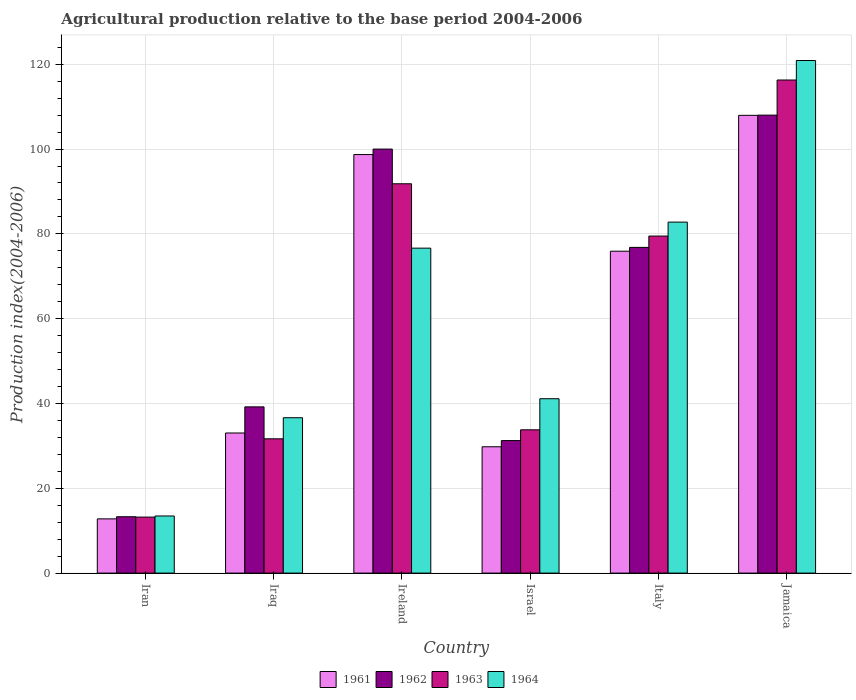How many different coloured bars are there?
Give a very brief answer. 4. Are the number of bars per tick equal to the number of legend labels?
Ensure brevity in your answer.  Yes. Are the number of bars on each tick of the X-axis equal?
Your answer should be very brief. Yes. How many bars are there on the 2nd tick from the right?
Your answer should be very brief. 4. What is the label of the 1st group of bars from the left?
Make the answer very short. Iran. What is the agricultural production index in 1964 in Italy?
Give a very brief answer. 82.77. Across all countries, what is the maximum agricultural production index in 1962?
Keep it short and to the point. 108. Across all countries, what is the minimum agricultural production index in 1964?
Make the answer very short. 13.47. In which country was the agricultural production index in 1961 maximum?
Offer a very short reply. Jamaica. In which country was the agricultural production index in 1961 minimum?
Offer a very short reply. Iran. What is the total agricultural production index in 1962 in the graph?
Your answer should be compact. 368.54. What is the difference between the agricultural production index in 1961 in Italy and that in Jamaica?
Provide a succinct answer. -32.04. What is the difference between the agricultural production index in 1961 in Iraq and the agricultural production index in 1963 in Ireland?
Give a very brief answer. -58.77. What is the average agricultural production index in 1963 per country?
Ensure brevity in your answer.  61.04. What is the difference between the agricultural production index of/in 1962 and agricultural production index of/in 1964 in Iran?
Your answer should be very brief. -0.18. What is the ratio of the agricultural production index in 1961 in Iraq to that in Italy?
Ensure brevity in your answer.  0.44. Is the agricultural production index in 1963 in Iraq less than that in Israel?
Ensure brevity in your answer.  Yes. What is the difference between the highest and the second highest agricultural production index in 1963?
Provide a short and direct response. -24.47. What is the difference between the highest and the lowest agricultural production index in 1962?
Provide a short and direct response. 94.71. In how many countries, is the agricultural production index in 1963 greater than the average agricultural production index in 1963 taken over all countries?
Your response must be concise. 3. Is the sum of the agricultural production index in 1963 in Iraq and Ireland greater than the maximum agricultural production index in 1961 across all countries?
Provide a short and direct response. Yes. Is it the case that in every country, the sum of the agricultural production index in 1963 and agricultural production index in 1962 is greater than the sum of agricultural production index in 1961 and agricultural production index in 1964?
Provide a succinct answer. No. Is it the case that in every country, the sum of the agricultural production index in 1962 and agricultural production index in 1964 is greater than the agricultural production index in 1963?
Your response must be concise. Yes. How many bars are there?
Offer a terse response. 24. How many countries are there in the graph?
Give a very brief answer. 6. Are the values on the major ticks of Y-axis written in scientific E-notation?
Provide a short and direct response. No. Does the graph contain any zero values?
Provide a short and direct response. No. What is the title of the graph?
Make the answer very short. Agricultural production relative to the base period 2004-2006. What is the label or title of the Y-axis?
Offer a terse response. Production index(2004-2006). What is the Production index(2004-2006) of 1961 in Iran?
Keep it short and to the point. 12.79. What is the Production index(2004-2006) in 1962 in Iran?
Give a very brief answer. 13.29. What is the Production index(2004-2006) of 1963 in Iran?
Offer a terse response. 13.21. What is the Production index(2004-2006) in 1964 in Iran?
Make the answer very short. 13.47. What is the Production index(2004-2006) of 1961 in Iraq?
Provide a short and direct response. 33.04. What is the Production index(2004-2006) in 1962 in Iraq?
Your response must be concise. 39.2. What is the Production index(2004-2006) in 1963 in Iraq?
Your response must be concise. 31.67. What is the Production index(2004-2006) in 1964 in Iraq?
Keep it short and to the point. 36.64. What is the Production index(2004-2006) in 1961 in Ireland?
Offer a terse response. 98.7. What is the Production index(2004-2006) in 1962 in Ireland?
Your answer should be very brief. 99.99. What is the Production index(2004-2006) of 1963 in Ireland?
Offer a terse response. 91.81. What is the Production index(2004-2006) in 1964 in Ireland?
Make the answer very short. 76.63. What is the Production index(2004-2006) of 1961 in Israel?
Provide a short and direct response. 29.79. What is the Production index(2004-2006) of 1962 in Israel?
Offer a very short reply. 31.25. What is the Production index(2004-2006) in 1963 in Israel?
Make the answer very short. 33.79. What is the Production index(2004-2006) in 1964 in Israel?
Offer a terse response. 41.12. What is the Production index(2004-2006) of 1961 in Italy?
Offer a very short reply. 75.91. What is the Production index(2004-2006) in 1962 in Italy?
Give a very brief answer. 76.81. What is the Production index(2004-2006) in 1963 in Italy?
Offer a very short reply. 79.48. What is the Production index(2004-2006) of 1964 in Italy?
Ensure brevity in your answer.  82.77. What is the Production index(2004-2006) of 1961 in Jamaica?
Keep it short and to the point. 107.95. What is the Production index(2004-2006) in 1962 in Jamaica?
Provide a short and direct response. 108. What is the Production index(2004-2006) of 1963 in Jamaica?
Your response must be concise. 116.28. What is the Production index(2004-2006) in 1964 in Jamaica?
Make the answer very short. 120.88. Across all countries, what is the maximum Production index(2004-2006) in 1961?
Make the answer very short. 107.95. Across all countries, what is the maximum Production index(2004-2006) of 1962?
Your answer should be very brief. 108. Across all countries, what is the maximum Production index(2004-2006) in 1963?
Provide a succinct answer. 116.28. Across all countries, what is the maximum Production index(2004-2006) of 1964?
Keep it short and to the point. 120.88. Across all countries, what is the minimum Production index(2004-2006) in 1961?
Your answer should be compact. 12.79. Across all countries, what is the minimum Production index(2004-2006) in 1962?
Offer a terse response. 13.29. Across all countries, what is the minimum Production index(2004-2006) in 1963?
Your answer should be compact. 13.21. Across all countries, what is the minimum Production index(2004-2006) of 1964?
Provide a succinct answer. 13.47. What is the total Production index(2004-2006) of 1961 in the graph?
Your response must be concise. 358.18. What is the total Production index(2004-2006) of 1962 in the graph?
Provide a short and direct response. 368.54. What is the total Production index(2004-2006) in 1963 in the graph?
Offer a terse response. 366.24. What is the total Production index(2004-2006) in 1964 in the graph?
Keep it short and to the point. 371.51. What is the difference between the Production index(2004-2006) of 1961 in Iran and that in Iraq?
Your answer should be very brief. -20.25. What is the difference between the Production index(2004-2006) in 1962 in Iran and that in Iraq?
Your response must be concise. -25.91. What is the difference between the Production index(2004-2006) in 1963 in Iran and that in Iraq?
Your answer should be compact. -18.46. What is the difference between the Production index(2004-2006) of 1964 in Iran and that in Iraq?
Your answer should be very brief. -23.17. What is the difference between the Production index(2004-2006) in 1961 in Iran and that in Ireland?
Provide a succinct answer. -85.91. What is the difference between the Production index(2004-2006) in 1962 in Iran and that in Ireland?
Your answer should be very brief. -86.7. What is the difference between the Production index(2004-2006) of 1963 in Iran and that in Ireland?
Your response must be concise. -78.6. What is the difference between the Production index(2004-2006) in 1964 in Iran and that in Ireland?
Provide a succinct answer. -63.16. What is the difference between the Production index(2004-2006) of 1962 in Iran and that in Israel?
Keep it short and to the point. -17.96. What is the difference between the Production index(2004-2006) in 1963 in Iran and that in Israel?
Keep it short and to the point. -20.58. What is the difference between the Production index(2004-2006) in 1964 in Iran and that in Israel?
Ensure brevity in your answer.  -27.65. What is the difference between the Production index(2004-2006) of 1961 in Iran and that in Italy?
Offer a very short reply. -63.12. What is the difference between the Production index(2004-2006) in 1962 in Iran and that in Italy?
Give a very brief answer. -63.52. What is the difference between the Production index(2004-2006) of 1963 in Iran and that in Italy?
Your answer should be very brief. -66.27. What is the difference between the Production index(2004-2006) of 1964 in Iran and that in Italy?
Your answer should be compact. -69.3. What is the difference between the Production index(2004-2006) in 1961 in Iran and that in Jamaica?
Make the answer very short. -95.16. What is the difference between the Production index(2004-2006) of 1962 in Iran and that in Jamaica?
Ensure brevity in your answer.  -94.71. What is the difference between the Production index(2004-2006) in 1963 in Iran and that in Jamaica?
Keep it short and to the point. -103.07. What is the difference between the Production index(2004-2006) of 1964 in Iran and that in Jamaica?
Ensure brevity in your answer.  -107.41. What is the difference between the Production index(2004-2006) of 1961 in Iraq and that in Ireland?
Provide a succinct answer. -65.66. What is the difference between the Production index(2004-2006) of 1962 in Iraq and that in Ireland?
Your answer should be compact. -60.79. What is the difference between the Production index(2004-2006) of 1963 in Iraq and that in Ireland?
Make the answer very short. -60.14. What is the difference between the Production index(2004-2006) of 1964 in Iraq and that in Ireland?
Offer a terse response. -39.99. What is the difference between the Production index(2004-2006) of 1961 in Iraq and that in Israel?
Your response must be concise. 3.25. What is the difference between the Production index(2004-2006) in 1962 in Iraq and that in Israel?
Your answer should be compact. 7.95. What is the difference between the Production index(2004-2006) in 1963 in Iraq and that in Israel?
Your response must be concise. -2.12. What is the difference between the Production index(2004-2006) in 1964 in Iraq and that in Israel?
Provide a short and direct response. -4.48. What is the difference between the Production index(2004-2006) of 1961 in Iraq and that in Italy?
Provide a succinct answer. -42.87. What is the difference between the Production index(2004-2006) in 1962 in Iraq and that in Italy?
Your response must be concise. -37.61. What is the difference between the Production index(2004-2006) in 1963 in Iraq and that in Italy?
Ensure brevity in your answer.  -47.81. What is the difference between the Production index(2004-2006) of 1964 in Iraq and that in Italy?
Provide a succinct answer. -46.13. What is the difference between the Production index(2004-2006) in 1961 in Iraq and that in Jamaica?
Ensure brevity in your answer.  -74.91. What is the difference between the Production index(2004-2006) of 1962 in Iraq and that in Jamaica?
Make the answer very short. -68.8. What is the difference between the Production index(2004-2006) of 1963 in Iraq and that in Jamaica?
Provide a short and direct response. -84.61. What is the difference between the Production index(2004-2006) of 1964 in Iraq and that in Jamaica?
Keep it short and to the point. -84.24. What is the difference between the Production index(2004-2006) in 1961 in Ireland and that in Israel?
Your answer should be very brief. 68.91. What is the difference between the Production index(2004-2006) of 1962 in Ireland and that in Israel?
Offer a terse response. 68.74. What is the difference between the Production index(2004-2006) in 1963 in Ireland and that in Israel?
Give a very brief answer. 58.02. What is the difference between the Production index(2004-2006) in 1964 in Ireland and that in Israel?
Provide a short and direct response. 35.51. What is the difference between the Production index(2004-2006) of 1961 in Ireland and that in Italy?
Offer a terse response. 22.79. What is the difference between the Production index(2004-2006) in 1962 in Ireland and that in Italy?
Provide a succinct answer. 23.18. What is the difference between the Production index(2004-2006) in 1963 in Ireland and that in Italy?
Provide a short and direct response. 12.33. What is the difference between the Production index(2004-2006) in 1964 in Ireland and that in Italy?
Your answer should be very brief. -6.14. What is the difference between the Production index(2004-2006) of 1961 in Ireland and that in Jamaica?
Provide a short and direct response. -9.25. What is the difference between the Production index(2004-2006) of 1962 in Ireland and that in Jamaica?
Offer a terse response. -8.01. What is the difference between the Production index(2004-2006) in 1963 in Ireland and that in Jamaica?
Offer a very short reply. -24.47. What is the difference between the Production index(2004-2006) in 1964 in Ireland and that in Jamaica?
Your answer should be very brief. -44.25. What is the difference between the Production index(2004-2006) in 1961 in Israel and that in Italy?
Your answer should be compact. -46.12. What is the difference between the Production index(2004-2006) of 1962 in Israel and that in Italy?
Keep it short and to the point. -45.56. What is the difference between the Production index(2004-2006) in 1963 in Israel and that in Italy?
Keep it short and to the point. -45.69. What is the difference between the Production index(2004-2006) in 1964 in Israel and that in Italy?
Your answer should be very brief. -41.65. What is the difference between the Production index(2004-2006) in 1961 in Israel and that in Jamaica?
Your response must be concise. -78.16. What is the difference between the Production index(2004-2006) in 1962 in Israel and that in Jamaica?
Offer a terse response. -76.75. What is the difference between the Production index(2004-2006) in 1963 in Israel and that in Jamaica?
Offer a very short reply. -82.49. What is the difference between the Production index(2004-2006) in 1964 in Israel and that in Jamaica?
Your response must be concise. -79.76. What is the difference between the Production index(2004-2006) in 1961 in Italy and that in Jamaica?
Your answer should be compact. -32.04. What is the difference between the Production index(2004-2006) in 1962 in Italy and that in Jamaica?
Offer a terse response. -31.19. What is the difference between the Production index(2004-2006) in 1963 in Italy and that in Jamaica?
Your response must be concise. -36.8. What is the difference between the Production index(2004-2006) in 1964 in Italy and that in Jamaica?
Offer a very short reply. -38.11. What is the difference between the Production index(2004-2006) of 1961 in Iran and the Production index(2004-2006) of 1962 in Iraq?
Give a very brief answer. -26.41. What is the difference between the Production index(2004-2006) of 1961 in Iran and the Production index(2004-2006) of 1963 in Iraq?
Ensure brevity in your answer.  -18.88. What is the difference between the Production index(2004-2006) in 1961 in Iran and the Production index(2004-2006) in 1964 in Iraq?
Provide a short and direct response. -23.85. What is the difference between the Production index(2004-2006) of 1962 in Iran and the Production index(2004-2006) of 1963 in Iraq?
Provide a succinct answer. -18.38. What is the difference between the Production index(2004-2006) in 1962 in Iran and the Production index(2004-2006) in 1964 in Iraq?
Ensure brevity in your answer.  -23.35. What is the difference between the Production index(2004-2006) in 1963 in Iran and the Production index(2004-2006) in 1964 in Iraq?
Your response must be concise. -23.43. What is the difference between the Production index(2004-2006) in 1961 in Iran and the Production index(2004-2006) in 1962 in Ireland?
Offer a very short reply. -87.2. What is the difference between the Production index(2004-2006) in 1961 in Iran and the Production index(2004-2006) in 1963 in Ireland?
Your response must be concise. -79.02. What is the difference between the Production index(2004-2006) of 1961 in Iran and the Production index(2004-2006) of 1964 in Ireland?
Offer a very short reply. -63.84. What is the difference between the Production index(2004-2006) of 1962 in Iran and the Production index(2004-2006) of 1963 in Ireland?
Your response must be concise. -78.52. What is the difference between the Production index(2004-2006) in 1962 in Iran and the Production index(2004-2006) in 1964 in Ireland?
Your response must be concise. -63.34. What is the difference between the Production index(2004-2006) in 1963 in Iran and the Production index(2004-2006) in 1964 in Ireland?
Provide a succinct answer. -63.42. What is the difference between the Production index(2004-2006) in 1961 in Iran and the Production index(2004-2006) in 1962 in Israel?
Your answer should be compact. -18.46. What is the difference between the Production index(2004-2006) in 1961 in Iran and the Production index(2004-2006) in 1963 in Israel?
Offer a terse response. -21. What is the difference between the Production index(2004-2006) of 1961 in Iran and the Production index(2004-2006) of 1964 in Israel?
Give a very brief answer. -28.33. What is the difference between the Production index(2004-2006) of 1962 in Iran and the Production index(2004-2006) of 1963 in Israel?
Offer a very short reply. -20.5. What is the difference between the Production index(2004-2006) of 1962 in Iran and the Production index(2004-2006) of 1964 in Israel?
Ensure brevity in your answer.  -27.83. What is the difference between the Production index(2004-2006) of 1963 in Iran and the Production index(2004-2006) of 1964 in Israel?
Keep it short and to the point. -27.91. What is the difference between the Production index(2004-2006) in 1961 in Iran and the Production index(2004-2006) in 1962 in Italy?
Provide a short and direct response. -64.02. What is the difference between the Production index(2004-2006) of 1961 in Iran and the Production index(2004-2006) of 1963 in Italy?
Offer a very short reply. -66.69. What is the difference between the Production index(2004-2006) of 1961 in Iran and the Production index(2004-2006) of 1964 in Italy?
Offer a very short reply. -69.98. What is the difference between the Production index(2004-2006) of 1962 in Iran and the Production index(2004-2006) of 1963 in Italy?
Keep it short and to the point. -66.19. What is the difference between the Production index(2004-2006) in 1962 in Iran and the Production index(2004-2006) in 1964 in Italy?
Give a very brief answer. -69.48. What is the difference between the Production index(2004-2006) in 1963 in Iran and the Production index(2004-2006) in 1964 in Italy?
Your answer should be very brief. -69.56. What is the difference between the Production index(2004-2006) in 1961 in Iran and the Production index(2004-2006) in 1962 in Jamaica?
Make the answer very short. -95.21. What is the difference between the Production index(2004-2006) of 1961 in Iran and the Production index(2004-2006) of 1963 in Jamaica?
Make the answer very short. -103.49. What is the difference between the Production index(2004-2006) in 1961 in Iran and the Production index(2004-2006) in 1964 in Jamaica?
Provide a succinct answer. -108.09. What is the difference between the Production index(2004-2006) in 1962 in Iran and the Production index(2004-2006) in 1963 in Jamaica?
Keep it short and to the point. -102.99. What is the difference between the Production index(2004-2006) of 1962 in Iran and the Production index(2004-2006) of 1964 in Jamaica?
Make the answer very short. -107.59. What is the difference between the Production index(2004-2006) of 1963 in Iran and the Production index(2004-2006) of 1964 in Jamaica?
Your response must be concise. -107.67. What is the difference between the Production index(2004-2006) of 1961 in Iraq and the Production index(2004-2006) of 1962 in Ireland?
Offer a very short reply. -66.95. What is the difference between the Production index(2004-2006) of 1961 in Iraq and the Production index(2004-2006) of 1963 in Ireland?
Offer a terse response. -58.77. What is the difference between the Production index(2004-2006) of 1961 in Iraq and the Production index(2004-2006) of 1964 in Ireland?
Give a very brief answer. -43.59. What is the difference between the Production index(2004-2006) in 1962 in Iraq and the Production index(2004-2006) in 1963 in Ireland?
Your answer should be very brief. -52.61. What is the difference between the Production index(2004-2006) in 1962 in Iraq and the Production index(2004-2006) in 1964 in Ireland?
Provide a succinct answer. -37.43. What is the difference between the Production index(2004-2006) in 1963 in Iraq and the Production index(2004-2006) in 1964 in Ireland?
Make the answer very short. -44.96. What is the difference between the Production index(2004-2006) of 1961 in Iraq and the Production index(2004-2006) of 1962 in Israel?
Your answer should be very brief. 1.79. What is the difference between the Production index(2004-2006) in 1961 in Iraq and the Production index(2004-2006) in 1963 in Israel?
Provide a succinct answer. -0.75. What is the difference between the Production index(2004-2006) of 1961 in Iraq and the Production index(2004-2006) of 1964 in Israel?
Your response must be concise. -8.08. What is the difference between the Production index(2004-2006) of 1962 in Iraq and the Production index(2004-2006) of 1963 in Israel?
Offer a terse response. 5.41. What is the difference between the Production index(2004-2006) in 1962 in Iraq and the Production index(2004-2006) in 1964 in Israel?
Offer a terse response. -1.92. What is the difference between the Production index(2004-2006) in 1963 in Iraq and the Production index(2004-2006) in 1964 in Israel?
Your answer should be very brief. -9.45. What is the difference between the Production index(2004-2006) of 1961 in Iraq and the Production index(2004-2006) of 1962 in Italy?
Make the answer very short. -43.77. What is the difference between the Production index(2004-2006) of 1961 in Iraq and the Production index(2004-2006) of 1963 in Italy?
Offer a very short reply. -46.44. What is the difference between the Production index(2004-2006) of 1961 in Iraq and the Production index(2004-2006) of 1964 in Italy?
Provide a succinct answer. -49.73. What is the difference between the Production index(2004-2006) in 1962 in Iraq and the Production index(2004-2006) in 1963 in Italy?
Offer a very short reply. -40.28. What is the difference between the Production index(2004-2006) of 1962 in Iraq and the Production index(2004-2006) of 1964 in Italy?
Make the answer very short. -43.57. What is the difference between the Production index(2004-2006) of 1963 in Iraq and the Production index(2004-2006) of 1964 in Italy?
Give a very brief answer. -51.1. What is the difference between the Production index(2004-2006) of 1961 in Iraq and the Production index(2004-2006) of 1962 in Jamaica?
Make the answer very short. -74.96. What is the difference between the Production index(2004-2006) of 1961 in Iraq and the Production index(2004-2006) of 1963 in Jamaica?
Keep it short and to the point. -83.24. What is the difference between the Production index(2004-2006) in 1961 in Iraq and the Production index(2004-2006) in 1964 in Jamaica?
Offer a terse response. -87.84. What is the difference between the Production index(2004-2006) in 1962 in Iraq and the Production index(2004-2006) in 1963 in Jamaica?
Ensure brevity in your answer.  -77.08. What is the difference between the Production index(2004-2006) of 1962 in Iraq and the Production index(2004-2006) of 1964 in Jamaica?
Your response must be concise. -81.68. What is the difference between the Production index(2004-2006) in 1963 in Iraq and the Production index(2004-2006) in 1964 in Jamaica?
Provide a short and direct response. -89.21. What is the difference between the Production index(2004-2006) of 1961 in Ireland and the Production index(2004-2006) of 1962 in Israel?
Ensure brevity in your answer.  67.45. What is the difference between the Production index(2004-2006) of 1961 in Ireland and the Production index(2004-2006) of 1963 in Israel?
Offer a very short reply. 64.91. What is the difference between the Production index(2004-2006) in 1961 in Ireland and the Production index(2004-2006) in 1964 in Israel?
Provide a succinct answer. 57.58. What is the difference between the Production index(2004-2006) in 1962 in Ireland and the Production index(2004-2006) in 1963 in Israel?
Make the answer very short. 66.2. What is the difference between the Production index(2004-2006) of 1962 in Ireland and the Production index(2004-2006) of 1964 in Israel?
Your answer should be very brief. 58.87. What is the difference between the Production index(2004-2006) of 1963 in Ireland and the Production index(2004-2006) of 1964 in Israel?
Your answer should be compact. 50.69. What is the difference between the Production index(2004-2006) in 1961 in Ireland and the Production index(2004-2006) in 1962 in Italy?
Give a very brief answer. 21.89. What is the difference between the Production index(2004-2006) in 1961 in Ireland and the Production index(2004-2006) in 1963 in Italy?
Your answer should be compact. 19.22. What is the difference between the Production index(2004-2006) in 1961 in Ireland and the Production index(2004-2006) in 1964 in Italy?
Make the answer very short. 15.93. What is the difference between the Production index(2004-2006) in 1962 in Ireland and the Production index(2004-2006) in 1963 in Italy?
Make the answer very short. 20.51. What is the difference between the Production index(2004-2006) of 1962 in Ireland and the Production index(2004-2006) of 1964 in Italy?
Offer a very short reply. 17.22. What is the difference between the Production index(2004-2006) in 1963 in Ireland and the Production index(2004-2006) in 1964 in Italy?
Give a very brief answer. 9.04. What is the difference between the Production index(2004-2006) in 1961 in Ireland and the Production index(2004-2006) in 1962 in Jamaica?
Your answer should be compact. -9.3. What is the difference between the Production index(2004-2006) of 1961 in Ireland and the Production index(2004-2006) of 1963 in Jamaica?
Your response must be concise. -17.58. What is the difference between the Production index(2004-2006) in 1961 in Ireland and the Production index(2004-2006) in 1964 in Jamaica?
Offer a very short reply. -22.18. What is the difference between the Production index(2004-2006) of 1962 in Ireland and the Production index(2004-2006) of 1963 in Jamaica?
Offer a very short reply. -16.29. What is the difference between the Production index(2004-2006) in 1962 in Ireland and the Production index(2004-2006) in 1964 in Jamaica?
Provide a succinct answer. -20.89. What is the difference between the Production index(2004-2006) in 1963 in Ireland and the Production index(2004-2006) in 1964 in Jamaica?
Ensure brevity in your answer.  -29.07. What is the difference between the Production index(2004-2006) of 1961 in Israel and the Production index(2004-2006) of 1962 in Italy?
Your answer should be compact. -47.02. What is the difference between the Production index(2004-2006) of 1961 in Israel and the Production index(2004-2006) of 1963 in Italy?
Offer a terse response. -49.69. What is the difference between the Production index(2004-2006) in 1961 in Israel and the Production index(2004-2006) in 1964 in Italy?
Your answer should be very brief. -52.98. What is the difference between the Production index(2004-2006) of 1962 in Israel and the Production index(2004-2006) of 1963 in Italy?
Offer a terse response. -48.23. What is the difference between the Production index(2004-2006) of 1962 in Israel and the Production index(2004-2006) of 1964 in Italy?
Offer a very short reply. -51.52. What is the difference between the Production index(2004-2006) of 1963 in Israel and the Production index(2004-2006) of 1964 in Italy?
Give a very brief answer. -48.98. What is the difference between the Production index(2004-2006) of 1961 in Israel and the Production index(2004-2006) of 1962 in Jamaica?
Provide a succinct answer. -78.21. What is the difference between the Production index(2004-2006) of 1961 in Israel and the Production index(2004-2006) of 1963 in Jamaica?
Provide a succinct answer. -86.49. What is the difference between the Production index(2004-2006) of 1961 in Israel and the Production index(2004-2006) of 1964 in Jamaica?
Your answer should be compact. -91.09. What is the difference between the Production index(2004-2006) of 1962 in Israel and the Production index(2004-2006) of 1963 in Jamaica?
Give a very brief answer. -85.03. What is the difference between the Production index(2004-2006) of 1962 in Israel and the Production index(2004-2006) of 1964 in Jamaica?
Ensure brevity in your answer.  -89.63. What is the difference between the Production index(2004-2006) of 1963 in Israel and the Production index(2004-2006) of 1964 in Jamaica?
Offer a terse response. -87.09. What is the difference between the Production index(2004-2006) of 1961 in Italy and the Production index(2004-2006) of 1962 in Jamaica?
Your answer should be very brief. -32.09. What is the difference between the Production index(2004-2006) in 1961 in Italy and the Production index(2004-2006) in 1963 in Jamaica?
Offer a terse response. -40.37. What is the difference between the Production index(2004-2006) in 1961 in Italy and the Production index(2004-2006) in 1964 in Jamaica?
Your response must be concise. -44.97. What is the difference between the Production index(2004-2006) of 1962 in Italy and the Production index(2004-2006) of 1963 in Jamaica?
Keep it short and to the point. -39.47. What is the difference between the Production index(2004-2006) in 1962 in Italy and the Production index(2004-2006) in 1964 in Jamaica?
Keep it short and to the point. -44.07. What is the difference between the Production index(2004-2006) of 1963 in Italy and the Production index(2004-2006) of 1964 in Jamaica?
Your response must be concise. -41.4. What is the average Production index(2004-2006) of 1961 per country?
Offer a terse response. 59.7. What is the average Production index(2004-2006) in 1962 per country?
Your answer should be very brief. 61.42. What is the average Production index(2004-2006) of 1963 per country?
Ensure brevity in your answer.  61.04. What is the average Production index(2004-2006) of 1964 per country?
Your answer should be compact. 61.92. What is the difference between the Production index(2004-2006) of 1961 and Production index(2004-2006) of 1962 in Iran?
Provide a succinct answer. -0.5. What is the difference between the Production index(2004-2006) in 1961 and Production index(2004-2006) in 1963 in Iran?
Your answer should be compact. -0.42. What is the difference between the Production index(2004-2006) in 1961 and Production index(2004-2006) in 1964 in Iran?
Offer a very short reply. -0.68. What is the difference between the Production index(2004-2006) of 1962 and Production index(2004-2006) of 1964 in Iran?
Provide a short and direct response. -0.18. What is the difference between the Production index(2004-2006) of 1963 and Production index(2004-2006) of 1964 in Iran?
Ensure brevity in your answer.  -0.26. What is the difference between the Production index(2004-2006) of 1961 and Production index(2004-2006) of 1962 in Iraq?
Make the answer very short. -6.16. What is the difference between the Production index(2004-2006) of 1961 and Production index(2004-2006) of 1963 in Iraq?
Your response must be concise. 1.37. What is the difference between the Production index(2004-2006) of 1962 and Production index(2004-2006) of 1963 in Iraq?
Your response must be concise. 7.53. What is the difference between the Production index(2004-2006) of 1962 and Production index(2004-2006) of 1964 in Iraq?
Make the answer very short. 2.56. What is the difference between the Production index(2004-2006) of 1963 and Production index(2004-2006) of 1964 in Iraq?
Keep it short and to the point. -4.97. What is the difference between the Production index(2004-2006) in 1961 and Production index(2004-2006) in 1962 in Ireland?
Your answer should be very brief. -1.29. What is the difference between the Production index(2004-2006) in 1961 and Production index(2004-2006) in 1963 in Ireland?
Provide a short and direct response. 6.89. What is the difference between the Production index(2004-2006) of 1961 and Production index(2004-2006) of 1964 in Ireland?
Your answer should be compact. 22.07. What is the difference between the Production index(2004-2006) in 1962 and Production index(2004-2006) in 1963 in Ireland?
Your answer should be compact. 8.18. What is the difference between the Production index(2004-2006) of 1962 and Production index(2004-2006) of 1964 in Ireland?
Your response must be concise. 23.36. What is the difference between the Production index(2004-2006) of 1963 and Production index(2004-2006) of 1964 in Ireland?
Offer a very short reply. 15.18. What is the difference between the Production index(2004-2006) of 1961 and Production index(2004-2006) of 1962 in Israel?
Your answer should be compact. -1.46. What is the difference between the Production index(2004-2006) in 1961 and Production index(2004-2006) in 1963 in Israel?
Your response must be concise. -4. What is the difference between the Production index(2004-2006) of 1961 and Production index(2004-2006) of 1964 in Israel?
Your answer should be very brief. -11.33. What is the difference between the Production index(2004-2006) of 1962 and Production index(2004-2006) of 1963 in Israel?
Your answer should be compact. -2.54. What is the difference between the Production index(2004-2006) of 1962 and Production index(2004-2006) of 1964 in Israel?
Provide a short and direct response. -9.87. What is the difference between the Production index(2004-2006) in 1963 and Production index(2004-2006) in 1964 in Israel?
Offer a very short reply. -7.33. What is the difference between the Production index(2004-2006) in 1961 and Production index(2004-2006) in 1963 in Italy?
Your answer should be very brief. -3.57. What is the difference between the Production index(2004-2006) of 1961 and Production index(2004-2006) of 1964 in Italy?
Keep it short and to the point. -6.86. What is the difference between the Production index(2004-2006) in 1962 and Production index(2004-2006) in 1963 in Italy?
Your answer should be very brief. -2.67. What is the difference between the Production index(2004-2006) of 1962 and Production index(2004-2006) of 1964 in Italy?
Your answer should be compact. -5.96. What is the difference between the Production index(2004-2006) of 1963 and Production index(2004-2006) of 1964 in Italy?
Provide a succinct answer. -3.29. What is the difference between the Production index(2004-2006) in 1961 and Production index(2004-2006) in 1962 in Jamaica?
Ensure brevity in your answer.  -0.05. What is the difference between the Production index(2004-2006) in 1961 and Production index(2004-2006) in 1963 in Jamaica?
Your answer should be very brief. -8.33. What is the difference between the Production index(2004-2006) in 1961 and Production index(2004-2006) in 1964 in Jamaica?
Your answer should be compact. -12.93. What is the difference between the Production index(2004-2006) in 1962 and Production index(2004-2006) in 1963 in Jamaica?
Offer a very short reply. -8.28. What is the difference between the Production index(2004-2006) in 1962 and Production index(2004-2006) in 1964 in Jamaica?
Your response must be concise. -12.88. What is the difference between the Production index(2004-2006) in 1963 and Production index(2004-2006) in 1964 in Jamaica?
Keep it short and to the point. -4.6. What is the ratio of the Production index(2004-2006) in 1961 in Iran to that in Iraq?
Give a very brief answer. 0.39. What is the ratio of the Production index(2004-2006) in 1962 in Iran to that in Iraq?
Keep it short and to the point. 0.34. What is the ratio of the Production index(2004-2006) in 1963 in Iran to that in Iraq?
Make the answer very short. 0.42. What is the ratio of the Production index(2004-2006) in 1964 in Iran to that in Iraq?
Offer a terse response. 0.37. What is the ratio of the Production index(2004-2006) of 1961 in Iran to that in Ireland?
Ensure brevity in your answer.  0.13. What is the ratio of the Production index(2004-2006) of 1962 in Iran to that in Ireland?
Your response must be concise. 0.13. What is the ratio of the Production index(2004-2006) of 1963 in Iran to that in Ireland?
Keep it short and to the point. 0.14. What is the ratio of the Production index(2004-2006) of 1964 in Iran to that in Ireland?
Ensure brevity in your answer.  0.18. What is the ratio of the Production index(2004-2006) of 1961 in Iran to that in Israel?
Make the answer very short. 0.43. What is the ratio of the Production index(2004-2006) in 1962 in Iran to that in Israel?
Make the answer very short. 0.43. What is the ratio of the Production index(2004-2006) of 1963 in Iran to that in Israel?
Offer a terse response. 0.39. What is the ratio of the Production index(2004-2006) in 1964 in Iran to that in Israel?
Your answer should be very brief. 0.33. What is the ratio of the Production index(2004-2006) in 1961 in Iran to that in Italy?
Provide a succinct answer. 0.17. What is the ratio of the Production index(2004-2006) in 1962 in Iran to that in Italy?
Your answer should be compact. 0.17. What is the ratio of the Production index(2004-2006) of 1963 in Iran to that in Italy?
Keep it short and to the point. 0.17. What is the ratio of the Production index(2004-2006) in 1964 in Iran to that in Italy?
Offer a terse response. 0.16. What is the ratio of the Production index(2004-2006) in 1961 in Iran to that in Jamaica?
Provide a short and direct response. 0.12. What is the ratio of the Production index(2004-2006) of 1962 in Iran to that in Jamaica?
Make the answer very short. 0.12. What is the ratio of the Production index(2004-2006) of 1963 in Iran to that in Jamaica?
Your response must be concise. 0.11. What is the ratio of the Production index(2004-2006) in 1964 in Iran to that in Jamaica?
Provide a succinct answer. 0.11. What is the ratio of the Production index(2004-2006) of 1961 in Iraq to that in Ireland?
Give a very brief answer. 0.33. What is the ratio of the Production index(2004-2006) of 1962 in Iraq to that in Ireland?
Your answer should be very brief. 0.39. What is the ratio of the Production index(2004-2006) in 1963 in Iraq to that in Ireland?
Your response must be concise. 0.34. What is the ratio of the Production index(2004-2006) in 1964 in Iraq to that in Ireland?
Provide a succinct answer. 0.48. What is the ratio of the Production index(2004-2006) of 1961 in Iraq to that in Israel?
Offer a very short reply. 1.11. What is the ratio of the Production index(2004-2006) in 1962 in Iraq to that in Israel?
Your answer should be compact. 1.25. What is the ratio of the Production index(2004-2006) in 1963 in Iraq to that in Israel?
Your answer should be compact. 0.94. What is the ratio of the Production index(2004-2006) in 1964 in Iraq to that in Israel?
Provide a short and direct response. 0.89. What is the ratio of the Production index(2004-2006) in 1961 in Iraq to that in Italy?
Your answer should be compact. 0.44. What is the ratio of the Production index(2004-2006) in 1962 in Iraq to that in Italy?
Keep it short and to the point. 0.51. What is the ratio of the Production index(2004-2006) in 1963 in Iraq to that in Italy?
Provide a short and direct response. 0.4. What is the ratio of the Production index(2004-2006) in 1964 in Iraq to that in Italy?
Provide a succinct answer. 0.44. What is the ratio of the Production index(2004-2006) in 1961 in Iraq to that in Jamaica?
Offer a terse response. 0.31. What is the ratio of the Production index(2004-2006) in 1962 in Iraq to that in Jamaica?
Offer a terse response. 0.36. What is the ratio of the Production index(2004-2006) in 1963 in Iraq to that in Jamaica?
Your response must be concise. 0.27. What is the ratio of the Production index(2004-2006) in 1964 in Iraq to that in Jamaica?
Your answer should be very brief. 0.3. What is the ratio of the Production index(2004-2006) in 1961 in Ireland to that in Israel?
Offer a terse response. 3.31. What is the ratio of the Production index(2004-2006) in 1962 in Ireland to that in Israel?
Your answer should be compact. 3.2. What is the ratio of the Production index(2004-2006) of 1963 in Ireland to that in Israel?
Provide a short and direct response. 2.72. What is the ratio of the Production index(2004-2006) of 1964 in Ireland to that in Israel?
Your response must be concise. 1.86. What is the ratio of the Production index(2004-2006) in 1961 in Ireland to that in Italy?
Make the answer very short. 1.3. What is the ratio of the Production index(2004-2006) of 1962 in Ireland to that in Italy?
Offer a very short reply. 1.3. What is the ratio of the Production index(2004-2006) of 1963 in Ireland to that in Italy?
Provide a short and direct response. 1.16. What is the ratio of the Production index(2004-2006) of 1964 in Ireland to that in Italy?
Offer a terse response. 0.93. What is the ratio of the Production index(2004-2006) of 1961 in Ireland to that in Jamaica?
Keep it short and to the point. 0.91. What is the ratio of the Production index(2004-2006) of 1962 in Ireland to that in Jamaica?
Provide a short and direct response. 0.93. What is the ratio of the Production index(2004-2006) in 1963 in Ireland to that in Jamaica?
Ensure brevity in your answer.  0.79. What is the ratio of the Production index(2004-2006) in 1964 in Ireland to that in Jamaica?
Make the answer very short. 0.63. What is the ratio of the Production index(2004-2006) of 1961 in Israel to that in Italy?
Give a very brief answer. 0.39. What is the ratio of the Production index(2004-2006) in 1962 in Israel to that in Italy?
Provide a succinct answer. 0.41. What is the ratio of the Production index(2004-2006) in 1963 in Israel to that in Italy?
Your response must be concise. 0.43. What is the ratio of the Production index(2004-2006) in 1964 in Israel to that in Italy?
Give a very brief answer. 0.5. What is the ratio of the Production index(2004-2006) of 1961 in Israel to that in Jamaica?
Offer a very short reply. 0.28. What is the ratio of the Production index(2004-2006) of 1962 in Israel to that in Jamaica?
Your answer should be compact. 0.29. What is the ratio of the Production index(2004-2006) of 1963 in Israel to that in Jamaica?
Keep it short and to the point. 0.29. What is the ratio of the Production index(2004-2006) in 1964 in Israel to that in Jamaica?
Make the answer very short. 0.34. What is the ratio of the Production index(2004-2006) of 1961 in Italy to that in Jamaica?
Offer a terse response. 0.7. What is the ratio of the Production index(2004-2006) in 1962 in Italy to that in Jamaica?
Make the answer very short. 0.71. What is the ratio of the Production index(2004-2006) of 1963 in Italy to that in Jamaica?
Your answer should be very brief. 0.68. What is the ratio of the Production index(2004-2006) of 1964 in Italy to that in Jamaica?
Give a very brief answer. 0.68. What is the difference between the highest and the second highest Production index(2004-2006) in 1961?
Offer a terse response. 9.25. What is the difference between the highest and the second highest Production index(2004-2006) of 1962?
Your answer should be very brief. 8.01. What is the difference between the highest and the second highest Production index(2004-2006) of 1963?
Your answer should be compact. 24.47. What is the difference between the highest and the second highest Production index(2004-2006) in 1964?
Keep it short and to the point. 38.11. What is the difference between the highest and the lowest Production index(2004-2006) of 1961?
Ensure brevity in your answer.  95.16. What is the difference between the highest and the lowest Production index(2004-2006) of 1962?
Your answer should be very brief. 94.71. What is the difference between the highest and the lowest Production index(2004-2006) of 1963?
Your response must be concise. 103.07. What is the difference between the highest and the lowest Production index(2004-2006) of 1964?
Keep it short and to the point. 107.41. 